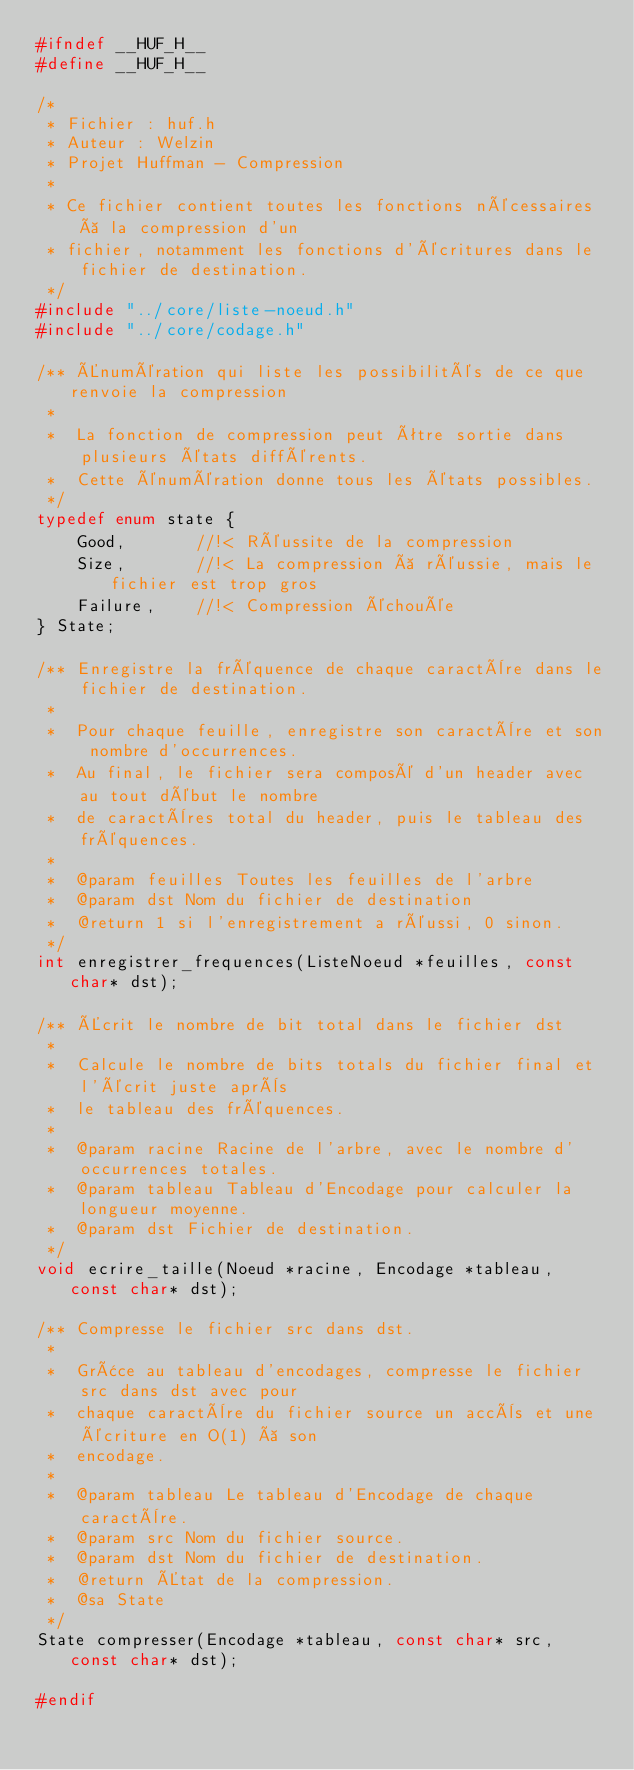Convert code to text. <code><loc_0><loc_0><loc_500><loc_500><_C_>#ifndef __HUF_H__
#define __HUF_H__

/*
 * Fichier : huf.h
 * Auteur : Welzin
 * Projet Huffman - Compression
 *
 * Ce fichier contient toutes les fonctions nécessaires à la compression d'un
 * fichier, notamment les fonctions d'écritures dans le fichier de destination.
 */
#include "../core/liste-noeud.h"
#include "../core/codage.h"

/** Énumération qui liste les possibilités de ce que renvoie la compression
 *
 *  La fonction de compression peut être sortie dans plusieurs états différents.
 *  Cette énumération donne tous les états possibles.
 */
typedef enum state {
    Good,       //!< Réussite de la compression
    Size,       //!< La compression à réussie, mais le fichier est trop gros
    Failure,    //!< Compression échouée
} State;

/** Enregistre la fréquence de chaque caractère dans le fichier de destination.
 *
 *  Pour chaque feuille, enregistre son caractère et son nombre d'occurrences.
 *  Au final, le fichier sera composé d'un header avec au tout début le nombre
 *  de caractères total du header, puis le tableau des fréquences.
 *
 *  @param feuilles Toutes les feuilles de l'arbre 
 *  @param dst Nom du fichier de destination
 *  @return 1 si l'enregistrement a réussi, 0 sinon.
 */
int enregistrer_frequences(ListeNoeud *feuilles, const char* dst);

/** Écrit le nombre de bit total dans le fichier dst
 *
 *  Calcule le nombre de bits totals du fichier final et l'écrit juste après
 *  le tableau des fréquences.
 *
 *  @param racine Racine de l'arbre, avec le nombre d'occurrences totales.
 *  @param tableau Tableau d'Encodage pour calculer la longueur moyenne.
 *  @param dst Fichier de destination.
 */
void ecrire_taille(Noeud *racine, Encodage *tableau, const char* dst);

/** Compresse le fichier src dans dst.
 *
 *  Grâce au tableau d'encodages, compresse le fichier src dans dst avec pour 
 *  chaque caractère du fichier source un accès et une écriture en O(1) à son 
 *  encodage.
 *
 *  @param tableau Le tableau d'Encodage de chaque caractère.
 *  @param src Nom du fichier source.
 *  @param dst Nom du fichier de destination.
 *  @return État de la compression.
 *  @sa State
 */
State compresser(Encodage *tableau, const char* src, const char* dst);

#endif</code> 